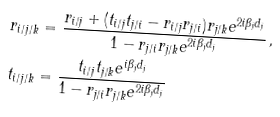<formula> <loc_0><loc_0><loc_500><loc_500>& r _ { i / j / k } = \frac { r _ { i / j } + ( t _ { i / j } t _ { j / i } - r _ { i / j } r _ { j / i } ) r _ { j / k } e ^ { 2 i \beta _ { j } d _ { j } } } { 1 - r _ { j / i } r _ { j / k } e ^ { 2 i \beta _ { j } d _ { j } } } \, , \\ & t _ { i / j / k } = \frac { t _ { i / j } t _ { j / k } e ^ { i \beta _ { j } d _ { j } } } { 1 - r _ { j / i } r _ { j / k } e ^ { 2 i \beta _ { j } d _ { j } } }</formula> 